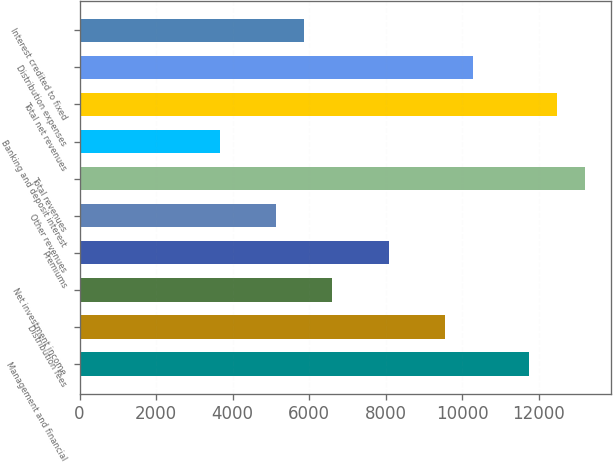<chart> <loc_0><loc_0><loc_500><loc_500><bar_chart><fcel>Management and financial<fcel>Distribution fees<fcel>Net investment income<fcel>Premiums<fcel>Other revenues<fcel>Total revenues<fcel>Banking and deposit interest<fcel>Total net revenues<fcel>Distribution expenses<fcel>Interest credited to fixed<nl><fcel>11745.5<fcel>9543.21<fcel>6606.89<fcel>8075.05<fcel>5138.73<fcel>13213.6<fcel>3670.57<fcel>12479.5<fcel>10277.3<fcel>5872.81<nl></chart> 